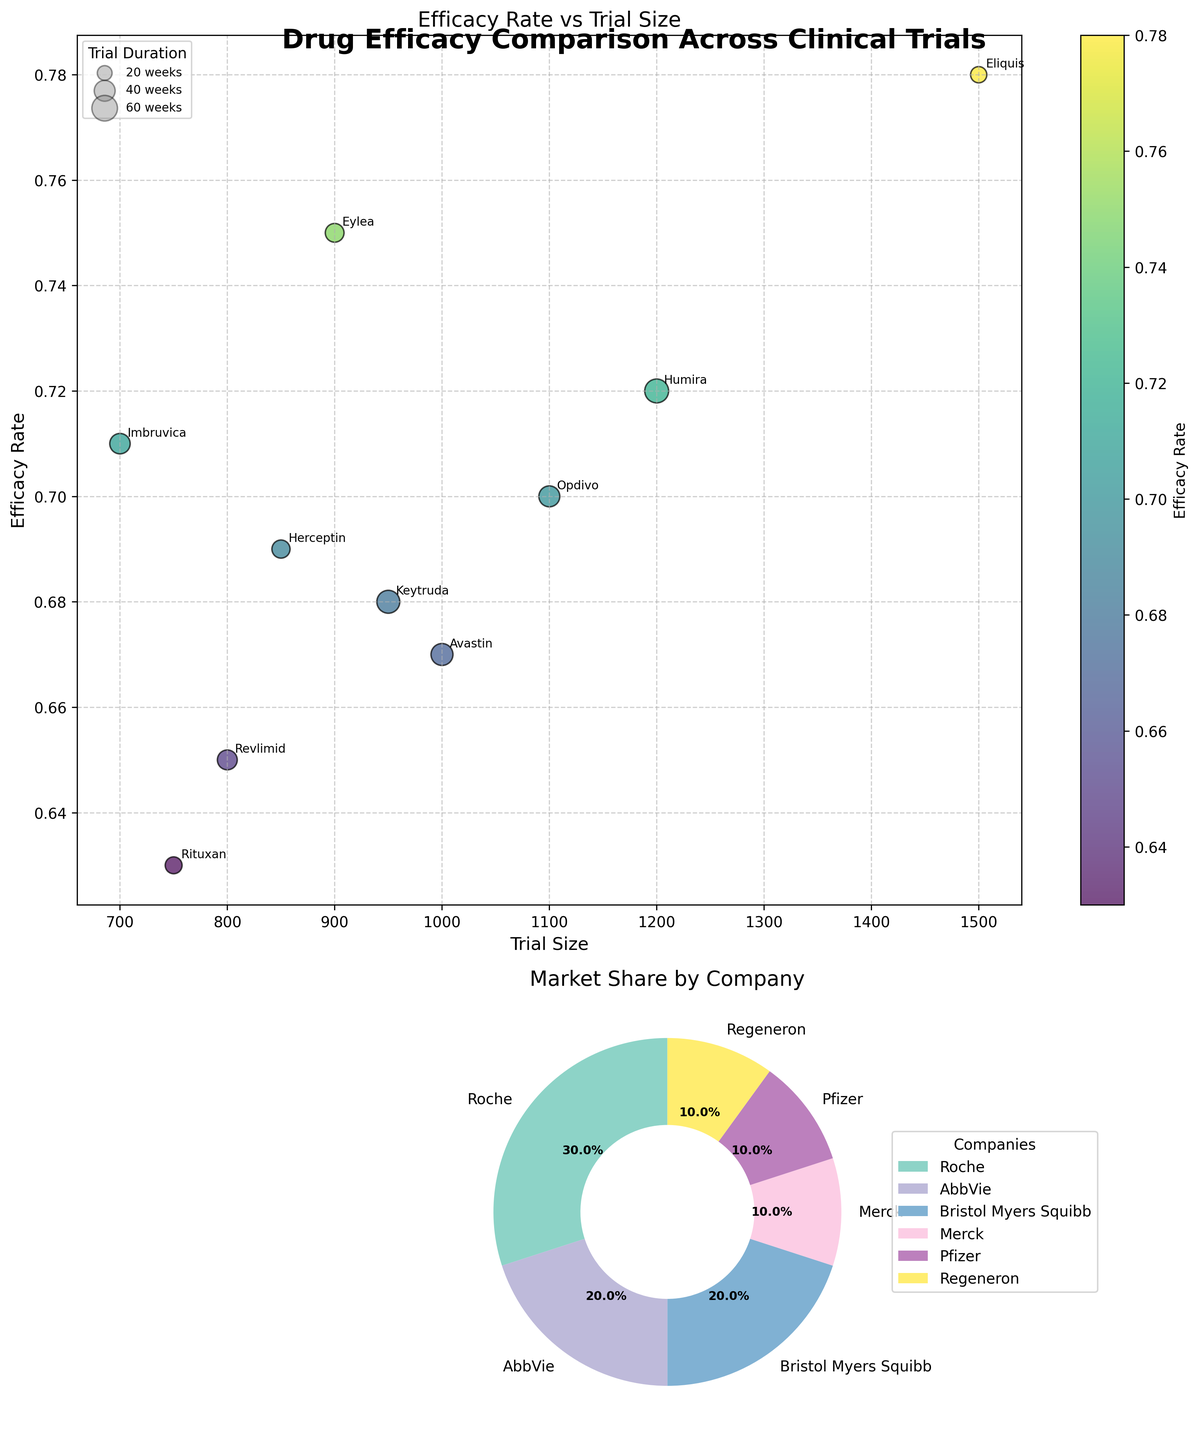What is the title of the scatter plot in the first subplot? The title of the scatter plot can be found at the top of the subplot.
Answer: Efficacy Rate vs Trial Size Which company conducted the clinical trial for the drug with the highest efficacy rate? Identify the drug with the highest efficacy rate from the scatter plot and then check the corresponding company from the annotations.
Answer: Pfizer What is the range of trial sizes represented in the scatter plot? The range of trial sizes can be determined by identifying the smallest and largest values along the x-axis in the scatter plot.
Answer: 700 to 1500 Compare the efficacy rates of Humira and Imbruvica. Which one is higher? Locate the data points for Humira and Imbruvica in the scatter plot and compare their y-values (efficacy rates).
Answer: Humira How many clinical trials did Roche conduct based on the market share pie chart? Count the number of segments labeled "Roche" in the pie chart to determine the number of clinical trials conducted by Roche.
Answer: 3 Which drug had the smallest trial size, and what is its efficacy rate? Identify the drug with the smallest trial size from the scatter plot's x-axis and then note its y-axis efficacy rate.
Answer: Imbruvica, 0.71 What is the average efficacy rate of the drugs whose trial sizes are greater than or equal to 1000? Identify the specific drugs/trial sizes greater than or equal to 1000, sum their efficacy rates, and divide by the number of such drugs. Detailed Explanation: 
- Drugs with trial sizes >= 1000: Humira (0.72), Eliquis (0.78), Opdivo (0.70), Avastin (0.67).
- Calculate the sum: 0.72 + 0.78 + 0.70 + 0.67 = 2.87.
- Calculate the average: 2.87 / 4 = 0.7175.
Answer: 0.72 How many companies have conducted only one clinical trial as displayed in the market share pie chart? Count the segments in the pie chart where a company appears just once.
Answer: 2 Which drug has the longest duration of its clinical trial and what is the duration? Identify the drug with the largest bubble in the scatter plot, as the size of the bubble represents the duration of the trial.
Answer: Humira, 52 weeks 